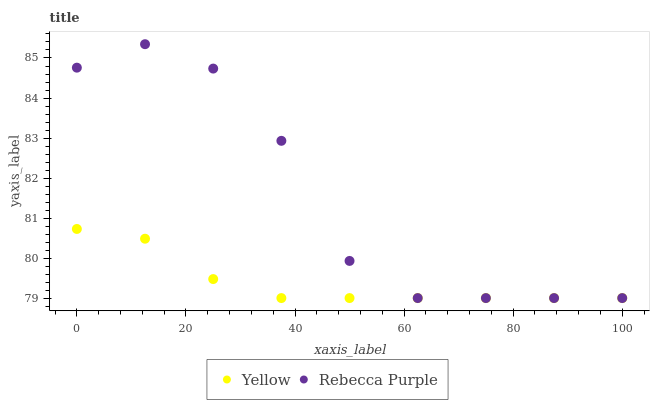Does Yellow have the minimum area under the curve?
Answer yes or no. Yes. Does Rebecca Purple have the maximum area under the curve?
Answer yes or no. Yes. Does Yellow have the maximum area under the curve?
Answer yes or no. No. Is Yellow the smoothest?
Answer yes or no. Yes. Is Rebecca Purple the roughest?
Answer yes or no. Yes. Is Yellow the roughest?
Answer yes or no. No. Does Rebecca Purple have the lowest value?
Answer yes or no. Yes. Does Rebecca Purple have the highest value?
Answer yes or no. Yes. Does Yellow have the highest value?
Answer yes or no. No. Does Rebecca Purple intersect Yellow?
Answer yes or no. Yes. Is Rebecca Purple less than Yellow?
Answer yes or no. No. Is Rebecca Purple greater than Yellow?
Answer yes or no. No. 